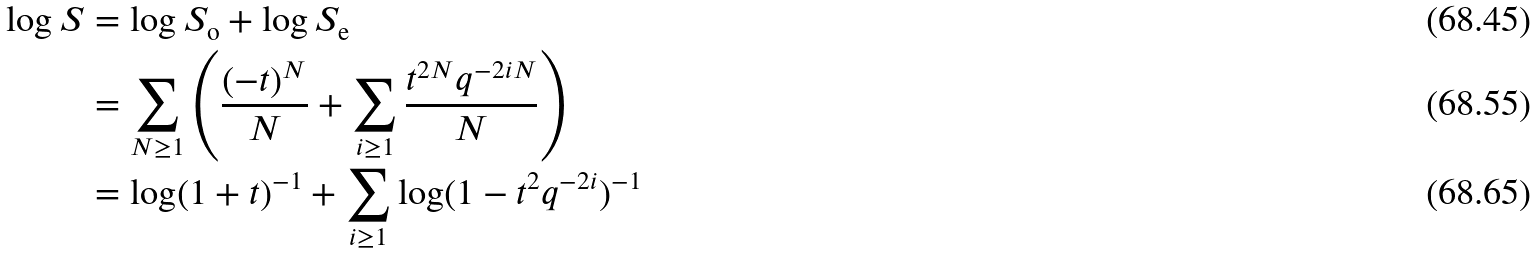<formula> <loc_0><loc_0><loc_500><loc_500>\log S & = \log S _ { \text {o} } + \log S _ { \text {e} } \\ & = \sum _ { N \geq 1 } \left ( \frac { ( - t ) ^ { N } } { N } + \sum _ { i \geq 1 } \frac { t ^ { 2 N } q ^ { - 2 i N } } { N } \right ) \\ & = \log ( 1 + t ) ^ { - 1 } + \sum _ { i \geq 1 } \log ( 1 - t ^ { 2 } q ^ { - 2 i } ) ^ { - 1 }</formula> 